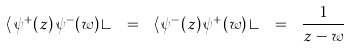<formula> <loc_0><loc_0><loc_500><loc_500>\langle \, \psi ^ { + } ( z ) \, \psi ^ { - } ( w ) \, \rangle \ = \ \langle \, \psi ^ { - } ( z ) \, \psi ^ { + } ( w ) \, \rangle \ = \ \frac { 1 } { z - w }</formula> 